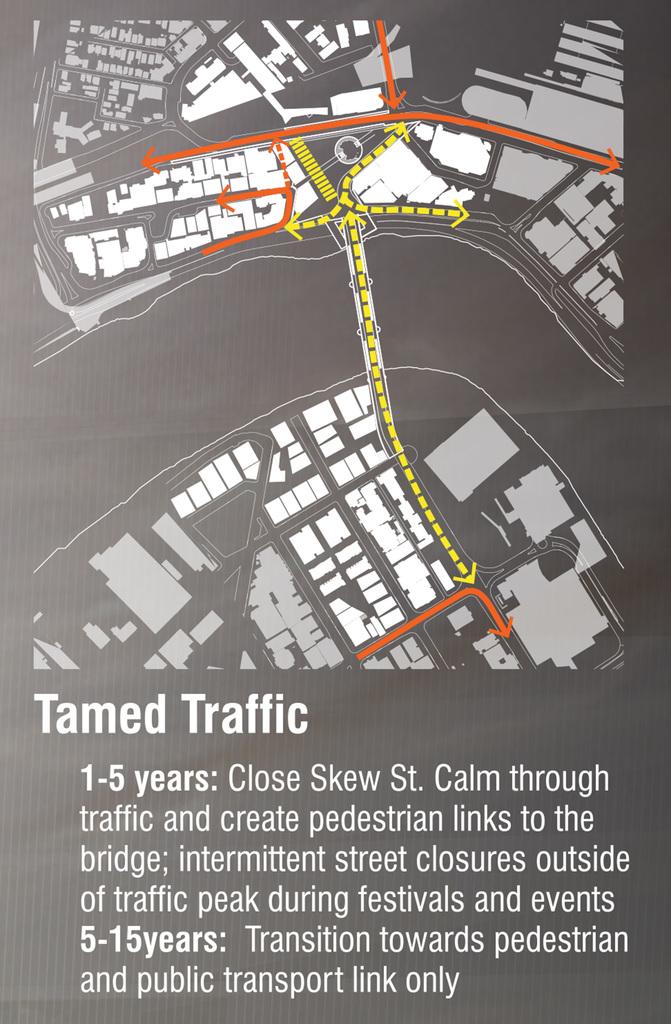How long until the transition towards pedestrian and public transport link?
Your answer should be compact. 5-15 years. What type of traffic is shown?
Ensure brevity in your answer.  Tamed. 